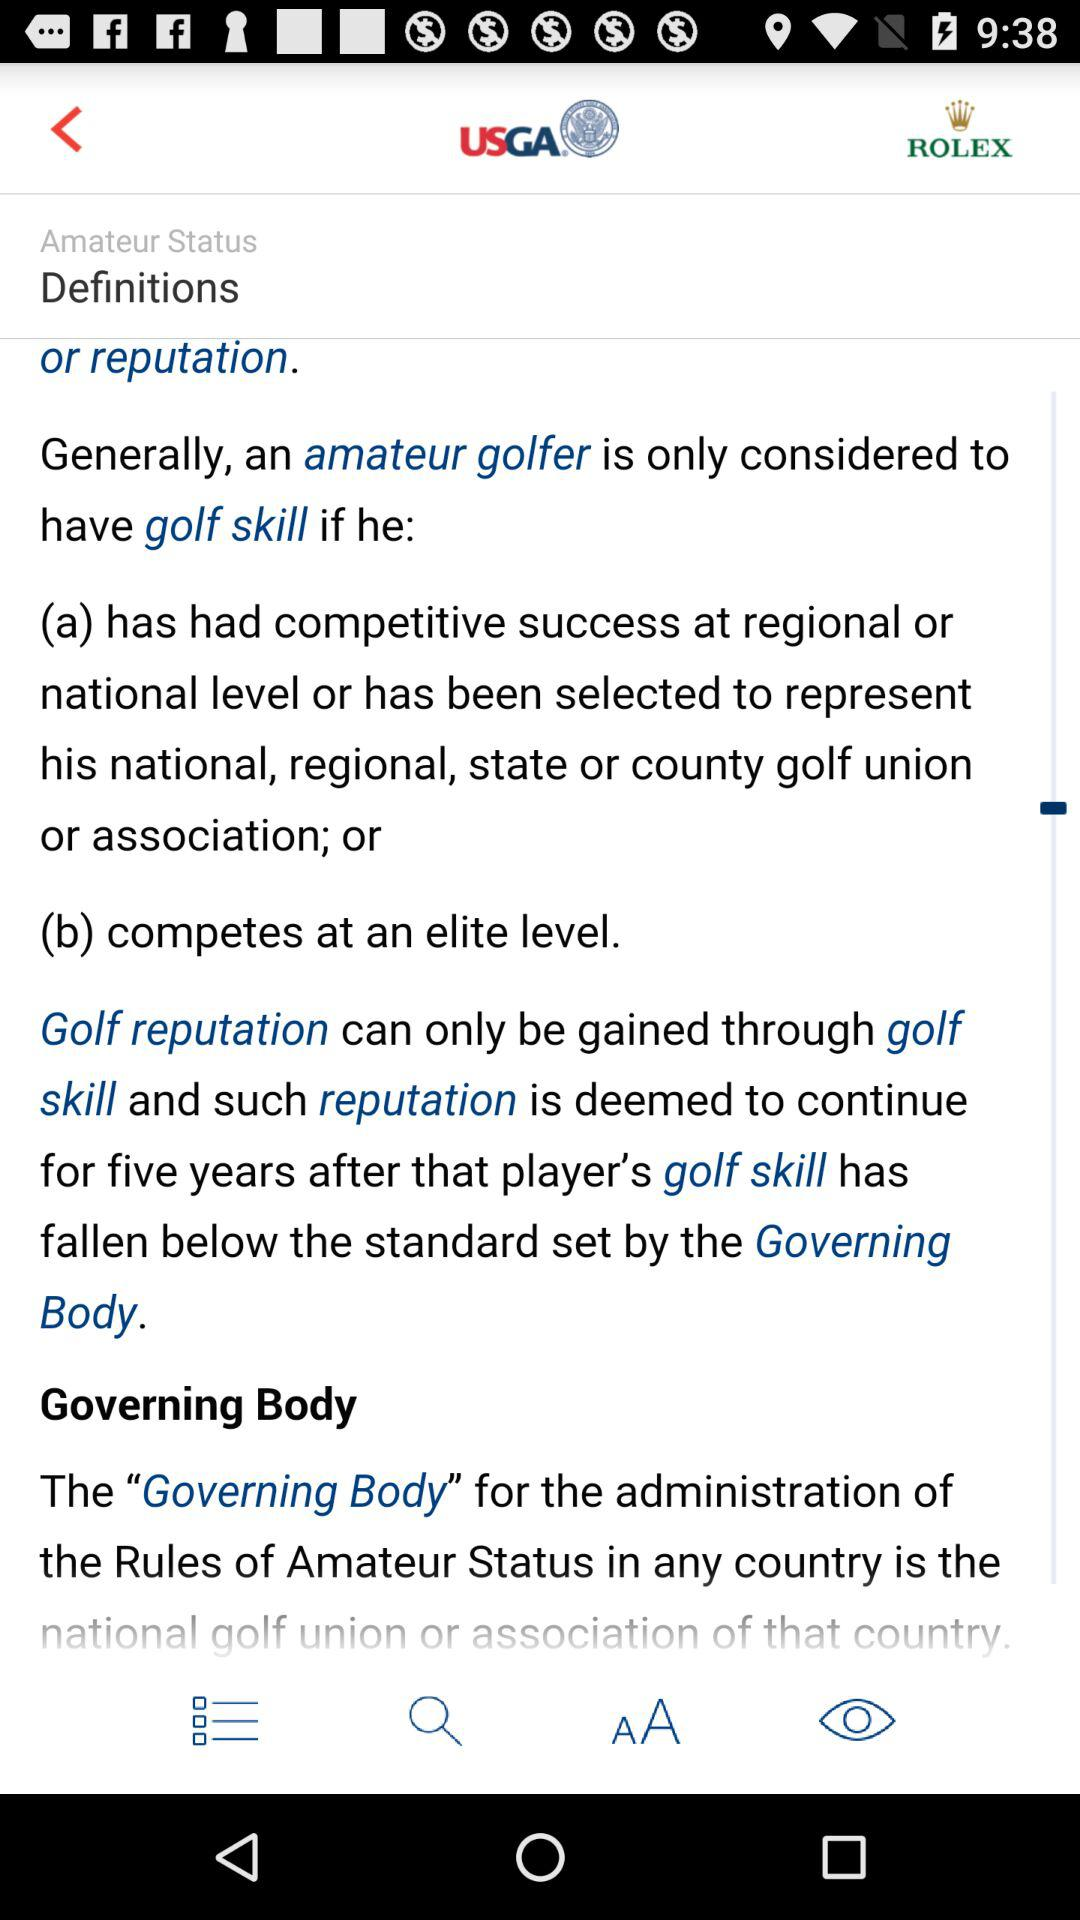Who sets the standards for golf skill? The standards for golf skills are set by the "Governing Body". 